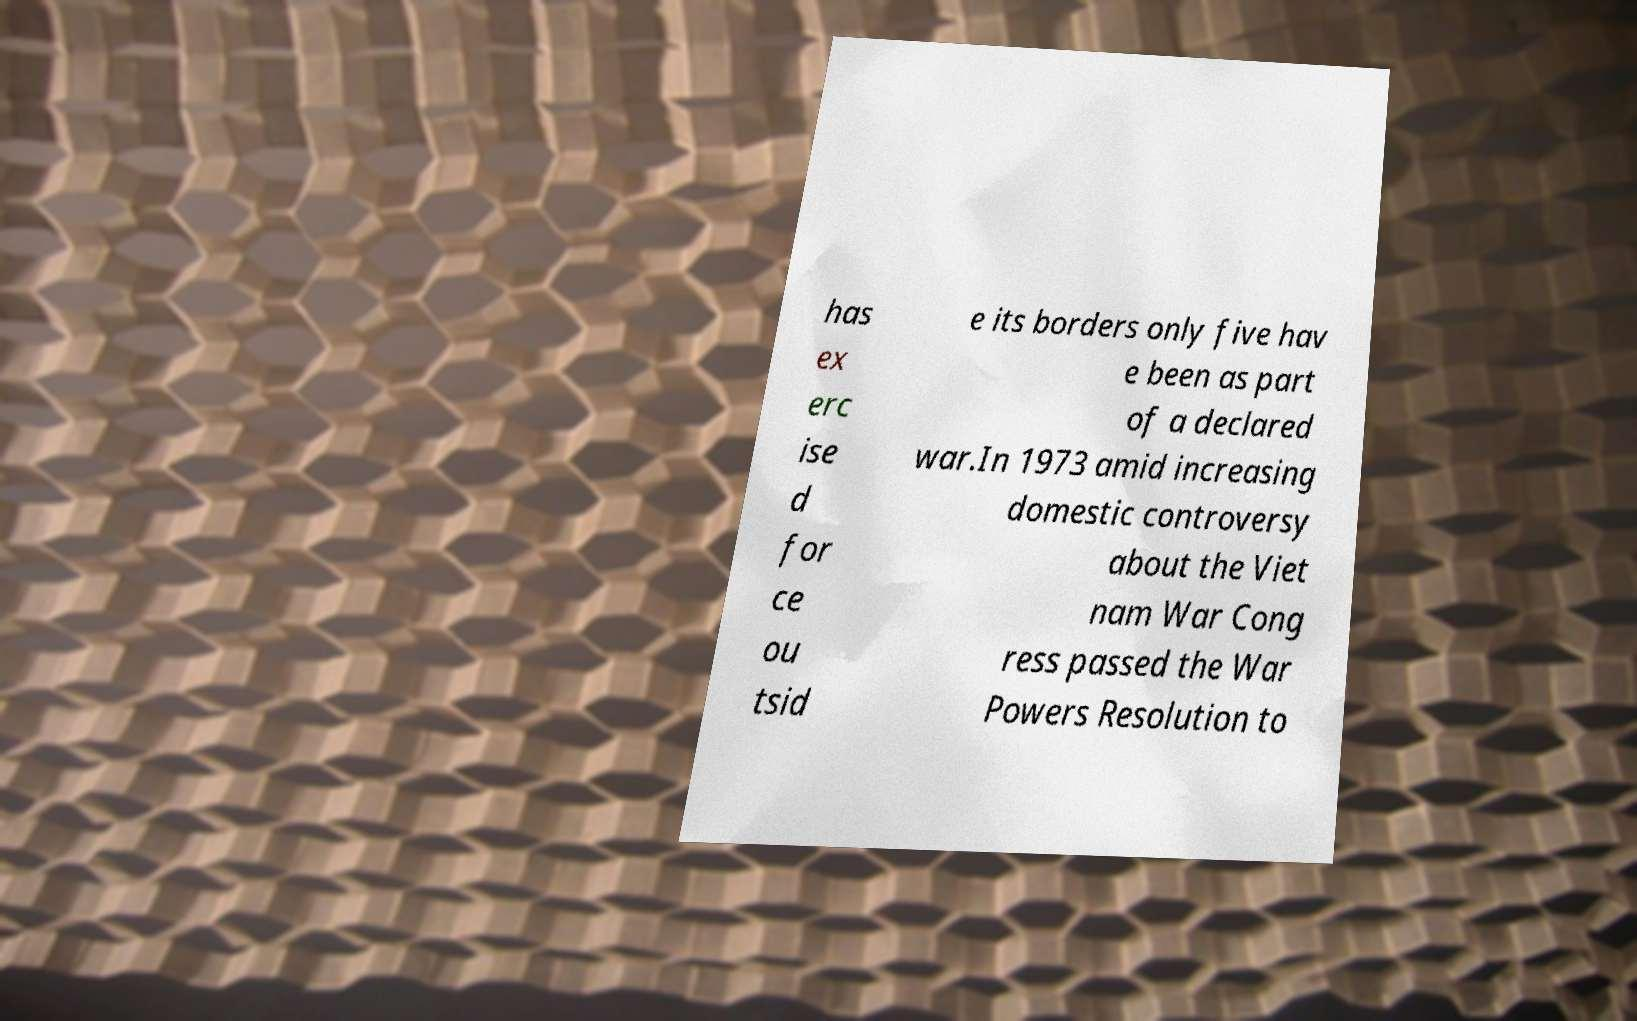I need the written content from this picture converted into text. Can you do that? has ex erc ise d for ce ou tsid e its borders only five hav e been as part of a declared war.In 1973 amid increasing domestic controversy about the Viet nam War Cong ress passed the War Powers Resolution to 